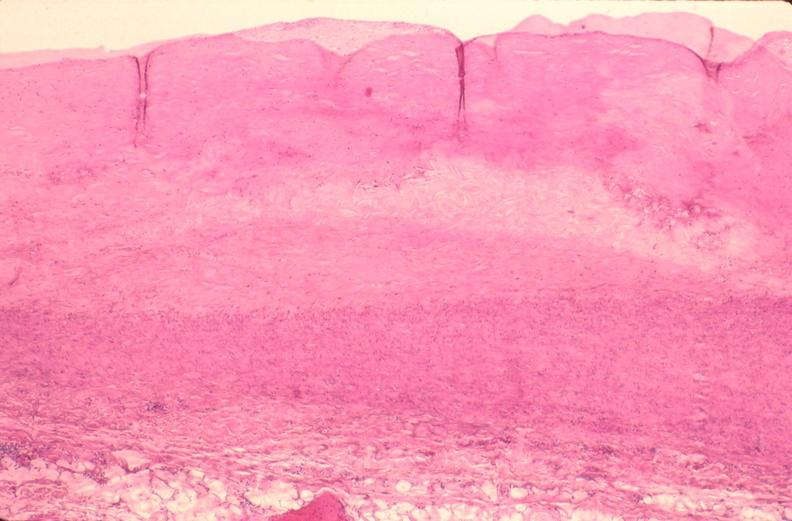s vasculature present?
Answer the question using a single word or phrase. Yes 